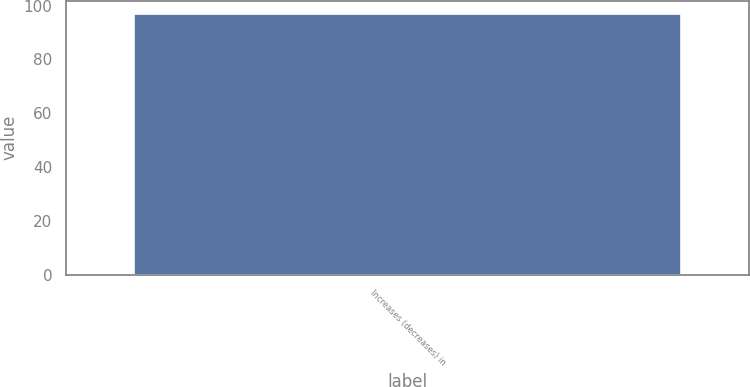<chart> <loc_0><loc_0><loc_500><loc_500><bar_chart><fcel>Increases (decreases) in<nl><fcel>97<nl></chart> 